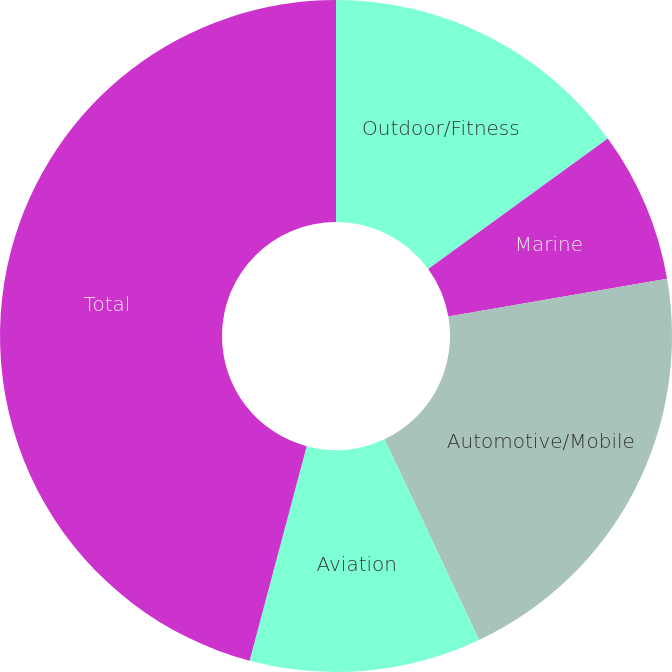Convert chart to OTSL. <chart><loc_0><loc_0><loc_500><loc_500><pie_chart><fcel>Outdoor/Fitness<fcel>Marine<fcel>Automotive/Mobile<fcel>Aviation<fcel>Total<nl><fcel>15.0%<fcel>7.28%<fcel>20.72%<fcel>11.14%<fcel>45.86%<nl></chart> 